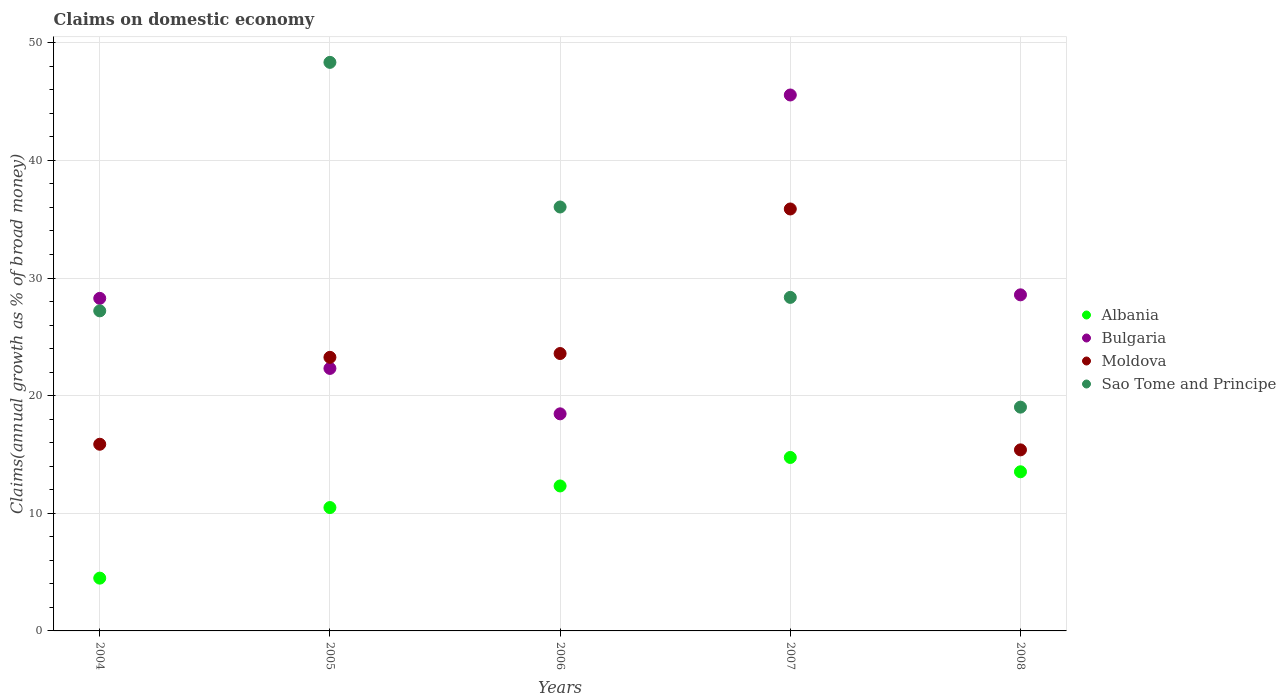How many different coloured dotlines are there?
Your answer should be compact. 4. Is the number of dotlines equal to the number of legend labels?
Your response must be concise. Yes. What is the percentage of broad money claimed on domestic economy in Moldova in 2005?
Your answer should be very brief. 23.26. Across all years, what is the maximum percentage of broad money claimed on domestic economy in Sao Tome and Principe?
Ensure brevity in your answer.  48.33. Across all years, what is the minimum percentage of broad money claimed on domestic economy in Sao Tome and Principe?
Give a very brief answer. 19.02. In which year was the percentage of broad money claimed on domestic economy in Sao Tome and Principe maximum?
Provide a short and direct response. 2005. What is the total percentage of broad money claimed on domestic economy in Bulgaria in the graph?
Keep it short and to the point. 143.17. What is the difference between the percentage of broad money claimed on domestic economy in Bulgaria in 2005 and that in 2008?
Give a very brief answer. -6.26. What is the difference between the percentage of broad money claimed on domestic economy in Albania in 2008 and the percentage of broad money claimed on domestic economy in Sao Tome and Principe in 2007?
Your response must be concise. -14.83. What is the average percentage of broad money claimed on domestic economy in Moldova per year?
Offer a very short reply. 22.79. In the year 2007, what is the difference between the percentage of broad money claimed on domestic economy in Albania and percentage of broad money claimed on domestic economy in Sao Tome and Principe?
Provide a succinct answer. -13.61. In how many years, is the percentage of broad money claimed on domestic economy in Bulgaria greater than 34 %?
Offer a terse response. 1. What is the ratio of the percentage of broad money claimed on domestic economy in Moldova in 2004 to that in 2006?
Keep it short and to the point. 0.67. Is the difference between the percentage of broad money claimed on domestic economy in Albania in 2005 and 2008 greater than the difference between the percentage of broad money claimed on domestic economy in Sao Tome and Principe in 2005 and 2008?
Give a very brief answer. No. What is the difference between the highest and the second highest percentage of broad money claimed on domestic economy in Sao Tome and Principe?
Offer a very short reply. 12.29. What is the difference between the highest and the lowest percentage of broad money claimed on domestic economy in Albania?
Offer a very short reply. 10.26. In how many years, is the percentage of broad money claimed on domestic economy in Sao Tome and Principe greater than the average percentage of broad money claimed on domestic economy in Sao Tome and Principe taken over all years?
Keep it short and to the point. 2. Is it the case that in every year, the sum of the percentage of broad money claimed on domestic economy in Sao Tome and Principe and percentage of broad money claimed on domestic economy in Bulgaria  is greater than the sum of percentage of broad money claimed on domestic economy in Albania and percentage of broad money claimed on domestic economy in Moldova?
Offer a very short reply. No. Is it the case that in every year, the sum of the percentage of broad money claimed on domestic economy in Sao Tome and Principe and percentage of broad money claimed on domestic economy in Albania  is greater than the percentage of broad money claimed on domestic economy in Moldova?
Keep it short and to the point. Yes. How many dotlines are there?
Give a very brief answer. 4. How many years are there in the graph?
Ensure brevity in your answer.  5. Are the values on the major ticks of Y-axis written in scientific E-notation?
Give a very brief answer. No. Does the graph contain any zero values?
Your response must be concise. No. How are the legend labels stacked?
Keep it short and to the point. Vertical. What is the title of the graph?
Your answer should be very brief. Claims on domestic economy. Does "Germany" appear as one of the legend labels in the graph?
Keep it short and to the point. No. What is the label or title of the Y-axis?
Give a very brief answer. Claims(annual growth as % of broad money). What is the Claims(annual growth as % of broad money) in Albania in 2004?
Give a very brief answer. 4.49. What is the Claims(annual growth as % of broad money) of Bulgaria in 2004?
Your answer should be compact. 28.27. What is the Claims(annual growth as % of broad money) in Moldova in 2004?
Ensure brevity in your answer.  15.87. What is the Claims(annual growth as % of broad money) in Sao Tome and Principe in 2004?
Provide a succinct answer. 27.21. What is the Claims(annual growth as % of broad money) of Albania in 2005?
Provide a short and direct response. 10.49. What is the Claims(annual growth as % of broad money) in Bulgaria in 2005?
Offer a very short reply. 22.32. What is the Claims(annual growth as % of broad money) of Moldova in 2005?
Ensure brevity in your answer.  23.26. What is the Claims(annual growth as % of broad money) in Sao Tome and Principe in 2005?
Provide a succinct answer. 48.33. What is the Claims(annual growth as % of broad money) of Albania in 2006?
Your answer should be compact. 12.32. What is the Claims(annual growth as % of broad money) of Bulgaria in 2006?
Offer a terse response. 18.45. What is the Claims(annual growth as % of broad money) in Moldova in 2006?
Your answer should be very brief. 23.58. What is the Claims(annual growth as % of broad money) of Sao Tome and Principe in 2006?
Your answer should be compact. 36.04. What is the Claims(annual growth as % of broad money) of Albania in 2007?
Make the answer very short. 14.75. What is the Claims(annual growth as % of broad money) in Bulgaria in 2007?
Give a very brief answer. 45.56. What is the Claims(annual growth as % of broad money) of Moldova in 2007?
Keep it short and to the point. 35.87. What is the Claims(annual growth as % of broad money) in Sao Tome and Principe in 2007?
Make the answer very short. 28.35. What is the Claims(annual growth as % of broad money) in Albania in 2008?
Your answer should be very brief. 13.53. What is the Claims(annual growth as % of broad money) of Bulgaria in 2008?
Your response must be concise. 28.57. What is the Claims(annual growth as % of broad money) of Moldova in 2008?
Ensure brevity in your answer.  15.39. What is the Claims(annual growth as % of broad money) in Sao Tome and Principe in 2008?
Keep it short and to the point. 19.02. Across all years, what is the maximum Claims(annual growth as % of broad money) in Albania?
Provide a short and direct response. 14.75. Across all years, what is the maximum Claims(annual growth as % of broad money) of Bulgaria?
Your answer should be compact. 45.56. Across all years, what is the maximum Claims(annual growth as % of broad money) of Moldova?
Give a very brief answer. 35.87. Across all years, what is the maximum Claims(annual growth as % of broad money) of Sao Tome and Principe?
Make the answer very short. 48.33. Across all years, what is the minimum Claims(annual growth as % of broad money) of Albania?
Offer a very short reply. 4.49. Across all years, what is the minimum Claims(annual growth as % of broad money) in Bulgaria?
Your answer should be compact. 18.45. Across all years, what is the minimum Claims(annual growth as % of broad money) in Moldova?
Provide a short and direct response. 15.39. Across all years, what is the minimum Claims(annual growth as % of broad money) in Sao Tome and Principe?
Offer a very short reply. 19.02. What is the total Claims(annual growth as % of broad money) in Albania in the graph?
Give a very brief answer. 55.57. What is the total Claims(annual growth as % of broad money) of Bulgaria in the graph?
Provide a succinct answer. 143.17. What is the total Claims(annual growth as % of broad money) in Moldova in the graph?
Your answer should be compact. 113.97. What is the total Claims(annual growth as % of broad money) in Sao Tome and Principe in the graph?
Offer a very short reply. 158.96. What is the difference between the Claims(annual growth as % of broad money) of Bulgaria in 2004 and that in 2005?
Your response must be concise. 5.96. What is the difference between the Claims(annual growth as % of broad money) of Moldova in 2004 and that in 2005?
Your answer should be very brief. -7.39. What is the difference between the Claims(annual growth as % of broad money) of Sao Tome and Principe in 2004 and that in 2005?
Provide a succinct answer. -21.12. What is the difference between the Claims(annual growth as % of broad money) in Albania in 2004 and that in 2006?
Offer a very short reply. -7.84. What is the difference between the Claims(annual growth as % of broad money) in Bulgaria in 2004 and that in 2006?
Ensure brevity in your answer.  9.82. What is the difference between the Claims(annual growth as % of broad money) of Moldova in 2004 and that in 2006?
Give a very brief answer. -7.71. What is the difference between the Claims(annual growth as % of broad money) in Sao Tome and Principe in 2004 and that in 2006?
Your answer should be compact. -8.83. What is the difference between the Claims(annual growth as % of broad money) in Albania in 2004 and that in 2007?
Give a very brief answer. -10.26. What is the difference between the Claims(annual growth as % of broad money) in Bulgaria in 2004 and that in 2007?
Provide a short and direct response. -17.29. What is the difference between the Claims(annual growth as % of broad money) in Moldova in 2004 and that in 2007?
Provide a succinct answer. -20. What is the difference between the Claims(annual growth as % of broad money) of Sao Tome and Principe in 2004 and that in 2007?
Give a very brief answer. -1.15. What is the difference between the Claims(annual growth as % of broad money) in Albania in 2004 and that in 2008?
Your response must be concise. -9.04. What is the difference between the Claims(annual growth as % of broad money) in Bulgaria in 2004 and that in 2008?
Offer a terse response. -0.3. What is the difference between the Claims(annual growth as % of broad money) of Moldova in 2004 and that in 2008?
Your answer should be compact. 0.48. What is the difference between the Claims(annual growth as % of broad money) of Sao Tome and Principe in 2004 and that in 2008?
Offer a very short reply. 8.18. What is the difference between the Claims(annual growth as % of broad money) of Albania in 2005 and that in 2006?
Your response must be concise. -1.84. What is the difference between the Claims(annual growth as % of broad money) of Bulgaria in 2005 and that in 2006?
Offer a terse response. 3.86. What is the difference between the Claims(annual growth as % of broad money) in Moldova in 2005 and that in 2006?
Provide a succinct answer. -0.32. What is the difference between the Claims(annual growth as % of broad money) of Sao Tome and Principe in 2005 and that in 2006?
Your answer should be compact. 12.29. What is the difference between the Claims(annual growth as % of broad money) in Albania in 2005 and that in 2007?
Provide a short and direct response. -4.26. What is the difference between the Claims(annual growth as % of broad money) of Bulgaria in 2005 and that in 2007?
Your answer should be very brief. -23.24. What is the difference between the Claims(annual growth as % of broad money) of Moldova in 2005 and that in 2007?
Provide a succinct answer. -12.61. What is the difference between the Claims(annual growth as % of broad money) of Sao Tome and Principe in 2005 and that in 2007?
Your answer should be very brief. 19.98. What is the difference between the Claims(annual growth as % of broad money) of Albania in 2005 and that in 2008?
Ensure brevity in your answer.  -3.04. What is the difference between the Claims(annual growth as % of broad money) of Bulgaria in 2005 and that in 2008?
Provide a succinct answer. -6.26. What is the difference between the Claims(annual growth as % of broad money) of Moldova in 2005 and that in 2008?
Make the answer very short. 7.87. What is the difference between the Claims(annual growth as % of broad money) of Sao Tome and Principe in 2005 and that in 2008?
Offer a terse response. 29.31. What is the difference between the Claims(annual growth as % of broad money) in Albania in 2006 and that in 2007?
Ensure brevity in your answer.  -2.42. What is the difference between the Claims(annual growth as % of broad money) in Bulgaria in 2006 and that in 2007?
Provide a short and direct response. -27.11. What is the difference between the Claims(annual growth as % of broad money) of Moldova in 2006 and that in 2007?
Provide a short and direct response. -12.29. What is the difference between the Claims(annual growth as % of broad money) in Sao Tome and Principe in 2006 and that in 2007?
Make the answer very short. 7.68. What is the difference between the Claims(annual growth as % of broad money) in Albania in 2006 and that in 2008?
Keep it short and to the point. -1.2. What is the difference between the Claims(annual growth as % of broad money) of Bulgaria in 2006 and that in 2008?
Keep it short and to the point. -10.12. What is the difference between the Claims(annual growth as % of broad money) of Moldova in 2006 and that in 2008?
Provide a short and direct response. 8.19. What is the difference between the Claims(annual growth as % of broad money) in Sao Tome and Principe in 2006 and that in 2008?
Offer a very short reply. 17.01. What is the difference between the Claims(annual growth as % of broad money) of Albania in 2007 and that in 2008?
Your answer should be compact. 1.22. What is the difference between the Claims(annual growth as % of broad money) of Bulgaria in 2007 and that in 2008?
Your response must be concise. 16.99. What is the difference between the Claims(annual growth as % of broad money) of Moldova in 2007 and that in 2008?
Provide a short and direct response. 20.48. What is the difference between the Claims(annual growth as % of broad money) of Sao Tome and Principe in 2007 and that in 2008?
Provide a short and direct response. 9.33. What is the difference between the Claims(annual growth as % of broad money) of Albania in 2004 and the Claims(annual growth as % of broad money) of Bulgaria in 2005?
Your answer should be compact. -17.83. What is the difference between the Claims(annual growth as % of broad money) of Albania in 2004 and the Claims(annual growth as % of broad money) of Moldova in 2005?
Ensure brevity in your answer.  -18.77. What is the difference between the Claims(annual growth as % of broad money) of Albania in 2004 and the Claims(annual growth as % of broad money) of Sao Tome and Principe in 2005?
Provide a short and direct response. -43.85. What is the difference between the Claims(annual growth as % of broad money) in Bulgaria in 2004 and the Claims(annual growth as % of broad money) in Moldova in 2005?
Provide a short and direct response. 5.01. What is the difference between the Claims(annual growth as % of broad money) in Bulgaria in 2004 and the Claims(annual growth as % of broad money) in Sao Tome and Principe in 2005?
Your answer should be compact. -20.06. What is the difference between the Claims(annual growth as % of broad money) of Moldova in 2004 and the Claims(annual growth as % of broad money) of Sao Tome and Principe in 2005?
Make the answer very short. -32.46. What is the difference between the Claims(annual growth as % of broad money) in Albania in 2004 and the Claims(annual growth as % of broad money) in Bulgaria in 2006?
Give a very brief answer. -13.97. What is the difference between the Claims(annual growth as % of broad money) in Albania in 2004 and the Claims(annual growth as % of broad money) in Moldova in 2006?
Provide a succinct answer. -19.09. What is the difference between the Claims(annual growth as % of broad money) of Albania in 2004 and the Claims(annual growth as % of broad money) of Sao Tome and Principe in 2006?
Provide a short and direct response. -31.55. What is the difference between the Claims(annual growth as % of broad money) in Bulgaria in 2004 and the Claims(annual growth as % of broad money) in Moldova in 2006?
Offer a terse response. 4.69. What is the difference between the Claims(annual growth as % of broad money) in Bulgaria in 2004 and the Claims(annual growth as % of broad money) in Sao Tome and Principe in 2006?
Your answer should be compact. -7.77. What is the difference between the Claims(annual growth as % of broad money) in Moldova in 2004 and the Claims(annual growth as % of broad money) in Sao Tome and Principe in 2006?
Offer a very short reply. -20.17. What is the difference between the Claims(annual growth as % of broad money) in Albania in 2004 and the Claims(annual growth as % of broad money) in Bulgaria in 2007?
Ensure brevity in your answer.  -41.07. What is the difference between the Claims(annual growth as % of broad money) in Albania in 2004 and the Claims(annual growth as % of broad money) in Moldova in 2007?
Give a very brief answer. -31.38. What is the difference between the Claims(annual growth as % of broad money) in Albania in 2004 and the Claims(annual growth as % of broad money) in Sao Tome and Principe in 2007?
Give a very brief answer. -23.87. What is the difference between the Claims(annual growth as % of broad money) in Bulgaria in 2004 and the Claims(annual growth as % of broad money) in Moldova in 2007?
Your answer should be compact. -7.6. What is the difference between the Claims(annual growth as % of broad money) of Bulgaria in 2004 and the Claims(annual growth as % of broad money) of Sao Tome and Principe in 2007?
Ensure brevity in your answer.  -0.08. What is the difference between the Claims(annual growth as % of broad money) of Moldova in 2004 and the Claims(annual growth as % of broad money) of Sao Tome and Principe in 2007?
Offer a very short reply. -12.48. What is the difference between the Claims(annual growth as % of broad money) in Albania in 2004 and the Claims(annual growth as % of broad money) in Bulgaria in 2008?
Offer a very short reply. -24.08. What is the difference between the Claims(annual growth as % of broad money) of Albania in 2004 and the Claims(annual growth as % of broad money) of Moldova in 2008?
Your answer should be compact. -10.9. What is the difference between the Claims(annual growth as % of broad money) in Albania in 2004 and the Claims(annual growth as % of broad money) in Sao Tome and Principe in 2008?
Offer a terse response. -14.54. What is the difference between the Claims(annual growth as % of broad money) of Bulgaria in 2004 and the Claims(annual growth as % of broad money) of Moldova in 2008?
Provide a succinct answer. 12.88. What is the difference between the Claims(annual growth as % of broad money) of Bulgaria in 2004 and the Claims(annual growth as % of broad money) of Sao Tome and Principe in 2008?
Ensure brevity in your answer.  9.25. What is the difference between the Claims(annual growth as % of broad money) of Moldova in 2004 and the Claims(annual growth as % of broad money) of Sao Tome and Principe in 2008?
Provide a succinct answer. -3.15. What is the difference between the Claims(annual growth as % of broad money) in Albania in 2005 and the Claims(annual growth as % of broad money) in Bulgaria in 2006?
Give a very brief answer. -7.97. What is the difference between the Claims(annual growth as % of broad money) of Albania in 2005 and the Claims(annual growth as % of broad money) of Moldova in 2006?
Provide a short and direct response. -13.09. What is the difference between the Claims(annual growth as % of broad money) in Albania in 2005 and the Claims(annual growth as % of broad money) in Sao Tome and Principe in 2006?
Ensure brevity in your answer.  -25.55. What is the difference between the Claims(annual growth as % of broad money) in Bulgaria in 2005 and the Claims(annual growth as % of broad money) in Moldova in 2006?
Offer a very short reply. -1.27. What is the difference between the Claims(annual growth as % of broad money) in Bulgaria in 2005 and the Claims(annual growth as % of broad money) in Sao Tome and Principe in 2006?
Your answer should be very brief. -13.72. What is the difference between the Claims(annual growth as % of broad money) of Moldova in 2005 and the Claims(annual growth as % of broad money) of Sao Tome and Principe in 2006?
Ensure brevity in your answer.  -12.78. What is the difference between the Claims(annual growth as % of broad money) of Albania in 2005 and the Claims(annual growth as % of broad money) of Bulgaria in 2007?
Give a very brief answer. -35.07. What is the difference between the Claims(annual growth as % of broad money) in Albania in 2005 and the Claims(annual growth as % of broad money) in Moldova in 2007?
Keep it short and to the point. -25.38. What is the difference between the Claims(annual growth as % of broad money) of Albania in 2005 and the Claims(annual growth as % of broad money) of Sao Tome and Principe in 2007?
Your answer should be very brief. -17.87. What is the difference between the Claims(annual growth as % of broad money) in Bulgaria in 2005 and the Claims(annual growth as % of broad money) in Moldova in 2007?
Offer a terse response. -13.55. What is the difference between the Claims(annual growth as % of broad money) of Bulgaria in 2005 and the Claims(annual growth as % of broad money) of Sao Tome and Principe in 2007?
Your answer should be very brief. -6.04. What is the difference between the Claims(annual growth as % of broad money) in Moldova in 2005 and the Claims(annual growth as % of broad money) in Sao Tome and Principe in 2007?
Give a very brief answer. -5.1. What is the difference between the Claims(annual growth as % of broad money) of Albania in 2005 and the Claims(annual growth as % of broad money) of Bulgaria in 2008?
Your answer should be very brief. -18.08. What is the difference between the Claims(annual growth as % of broad money) in Albania in 2005 and the Claims(annual growth as % of broad money) in Moldova in 2008?
Your answer should be very brief. -4.9. What is the difference between the Claims(annual growth as % of broad money) in Albania in 2005 and the Claims(annual growth as % of broad money) in Sao Tome and Principe in 2008?
Ensure brevity in your answer.  -8.54. What is the difference between the Claims(annual growth as % of broad money) of Bulgaria in 2005 and the Claims(annual growth as % of broad money) of Moldova in 2008?
Your response must be concise. 6.92. What is the difference between the Claims(annual growth as % of broad money) in Bulgaria in 2005 and the Claims(annual growth as % of broad money) in Sao Tome and Principe in 2008?
Give a very brief answer. 3.29. What is the difference between the Claims(annual growth as % of broad money) in Moldova in 2005 and the Claims(annual growth as % of broad money) in Sao Tome and Principe in 2008?
Offer a very short reply. 4.23. What is the difference between the Claims(annual growth as % of broad money) of Albania in 2006 and the Claims(annual growth as % of broad money) of Bulgaria in 2007?
Provide a short and direct response. -33.24. What is the difference between the Claims(annual growth as % of broad money) in Albania in 2006 and the Claims(annual growth as % of broad money) in Moldova in 2007?
Your response must be concise. -23.55. What is the difference between the Claims(annual growth as % of broad money) of Albania in 2006 and the Claims(annual growth as % of broad money) of Sao Tome and Principe in 2007?
Your answer should be very brief. -16.03. What is the difference between the Claims(annual growth as % of broad money) of Bulgaria in 2006 and the Claims(annual growth as % of broad money) of Moldova in 2007?
Your answer should be compact. -17.41. What is the difference between the Claims(annual growth as % of broad money) of Bulgaria in 2006 and the Claims(annual growth as % of broad money) of Sao Tome and Principe in 2007?
Offer a very short reply. -9.9. What is the difference between the Claims(annual growth as % of broad money) of Moldova in 2006 and the Claims(annual growth as % of broad money) of Sao Tome and Principe in 2007?
Make the answer very short. -4.77. What is the difference between the Claims(annual growth as % of broad money) of Albania in 2006 and the Claims(annual growth as % of broad money) of Bulgaria in 2008?
Keep it short and to the point. -16.25. What is the difference between the Claims(annual growth as % of broad money) in Albania in 2006 and the Claims(annual growth as % of broad money) in Moldova in 2008?
Your response must be concise. -3.07. What is the difference between the Claims(annual growth as % of broad money) of Albania in 2006 and the Claims(annual growth as % of broad money) of Sao Tome and Principe in 2008?
Keep it short and to the point. -6.7. What is the difference between the Claims(annual growth as % of broad money) of Bulgaria in 2006 and the Claims(annual growth as % of broad money) of Moldova in 2008?
Provide a short and direct response. 3.06. What is the difference between the Claims(annual growth as % of broad money) in Bulgaria in 2006 and the Claims(annual growth as % of broad money) in Sao Tome and Principe in 2008?
Provide a short and direct response. -0.57. What is the difference between the Claims(annual growth as % of broad money) of Moldova in 2006 and the Claims(annual growth as % of broad money) of Sao Tome and Principe in 2008?
Provide a short and direct response. 4.56. What is the difference between the Claims(annual growth as % of broad money) in Albania in 2007 and the Claims(annual growth as % of broad money) in Bulgaria in 2008?
Your answer should be very brief. -13.82. What is the difference between the Claims(annual growth as % of broad money) of Albania in 2007 and the Claims(annual growth as % of broad money) of Moldova in 2008?
Offer a terse response. -0.65. What is the difference between the Claims(annual growth as % of broad money) in Albania in 2007 and the Claims(annual growth as % of broad money) in Sao Tome and Principe in 2008?
Your answer should be compact. -4.28. What is the difference between the Claims(annual growth as % of broad money) of Bulgaria in 2007 and the Claims(annual growth as % of broad money) of Moldova in 2008?
Your response must be concise. 30.17. What is the difference between the Claims(annual growth as % of broad money) in Bulgaria in 2007 and the Claims(annual growth as % of broad money) in Sao Tome and Principe in 2008?
Offer a terse response. 26.54. What is the difference between the Claims(annual growth as % of broad money) in Moldova in 2007 and the Claims(annual growth as % of broad money) in Sao Tome and Principe in 2008?
Keep it short and to the point. 16.85. What is the average Claims(annual growth as % of broad money) in Albania per year?
Provide a short and direct response. 11.11. What is the average Claims(annual growth as % of broad money) of Bulgaria per year?
Your answer should be very brief. 28.63. What is the average Claims(annual growth as % of broad money) in Moldova per year?
Ensure brevity in your answer.  22.79. What is the average Claims(annual growth as % of broad money) of Sao Tome and Principe per year?
Offer a terse response. 31.79. In the year 2004, what is the difference between the Claims(annual growth as % of broad money) in Albania and Claims(annual growth as % of broad money) in Bulgaria?
Make the answer very short. -23.78. In the year 2004, what is the difference between the Claims(annual growth as % of broad money) in Albania and Claims(annual growth as % of broad money) in Moldova?
Give a very brief answer. -11.38. In the year 2004, what is the difference between the Claims(annual growth as % of broad money) of Albania and Claims(annual growth as % of broad money) of Sao Tome and Principe?
Keep it short and to the point. -22.72. In the year 2004, what is the difference between the Claims(annual growth as % of broad money) of Bulgaria and Claims(annual growth as % of broad money) of Moldova?
Keep it short and to the point. 12.4. In the year 2004, what is the difference between the Claims(annual growth as % of broad money) in Bulgaria and Claims(annual growth as % of broad money) in Sao Tome and Principe?
Provide a succinct answer. 1.06. In the year 2004, what is the difference between the Claims(annual growth as % of broad money) in Moldova and Claims(annual growth as % of broad money) in Sao Tome and Principe?
Your answer should be very brief. -11.34. In the year 2005, what is the difference between the Claims(annual growth as % of broad money) of Albania and Claims(annual growth as % of broad money) of Bulgaria?
Provide a short and direct response. -11.83. In the year 2005, what is the difference between the Claims(annual growth as % of broad money) in Albania and Claims(annual growth as % of broad money) in Moldova?
Your answer should be compact. -12.77. In the year 2005, what is the difference between the Claims(annual growth as % of broad money) of Albania and Claims(annual growth as % of broad money) of Sao Tome and Principe?
Give a very brief answer. -37.85. In the year 2005, what is the difference between the Claims(annual growth as % of broad money) of Bulgaria and Claims(annual growth as % of broad money) of Moldova?
Your response must be concise. -0.94. In the year 2005, what is the difference between the Claims(annual growth as % of broad money) of Bulgaria and Claims(annual growth as % of broad money) of Sao Tome and Principe?
Your answer should be very brief. -26.02. In the year 2005, what is the difference between the Claims(annual growth as % of broad money) of Moldova and Claims(annual growth as % of broad money) of Sao Tome and Principe?
Offer a terse response. -25.08. In the year 2006, what is the difference between the Claims(annual growth as % of broad money) of Albania and Claims(annual growth as % of broad money) of Bulgaria?
Offer a terse response. -6.13. In the year 2006, what is the difference between the Claims(annual growth as % of broad money) of Albania and Claims(annual growth as % of broad money) of Moldova?
Keep it short and to the point. -11.26. In the year 2006, what is the difference between the Claims(annual growth as % of broad money) of Albania and Claims(annual growth as % of broad money) of Sao Tome and Principe?
Provide a short and direct response. -23.71. In the year 2006, what is the difference between the Claims(annual growth as % of broad money) in Bulgaria and Claims(annual growth as % of broad money) in Moldova?
Your answer should be compact. -5.13. In the year 2006, what is the difference between the Claims(annual growth as % of broad money) of Bulgaria and Claims(annual growth as % of broad money) of Sao Tome and Principe?
Ensure brevity in your answer.  -17.58. In the year 2006, what is the difference between the Claims(annual growth as % of broad money) in Moldova and Claims(annual growth as % of broad money) in Sao Tome and Principe?
Make the answer very short. -12.46. In the year 2007, what is the difference between the Claims(annual growth as % of broad money) in Albania and Claims(annual growth as % of broad money) in Bulgaria?
Give a very brief answer. -30.81. In the year 2007, what is the difference between the Claims(annual growth as % of broad money) of Albania and Claims(annual growth as % of broad money) of Moldova?
Provide a succinct answer. -21.12. In the year 2007, what is the difference between the Claims(annual growth as % of broad money) of Albania and Claims(annual growth as % of broad money) of Sao Tome and Principe?
Keep it short and to the point. -13.61. In the year 2007, what is the difference between the Claims(annual growth as % of broad money) of Bulgaria and Claims(annual growth as % of broad money) of Moldova?
Provide a short and direct response. 9.69. In the year 2007, what is the difference between the Claims(annual growth as % of broad money) of Bulgaria and Claims(annual growth as % of broad money) of Sao Tome and Principe?
Keep it short and to the point. 17.21. In the year 2007, what is the difference between the Claims(annual growth as % of broad money) of Moldova and Claims(annual growth as % of broad money) of Sao Tome and Principe?
Offer a terse response. 7.52. In the year 2008, what is the difference between the Claims(annual growth as % of broad money) in Albania and Claims(annual growth as % of broad money) in Bulgaria?
Keep it short and to the point. -15.04. In the year 2008, what is the difference between the Claims(annual growth as % of broad money) in Albania and Claims(annual growth as % of broad money) in Moldova?
Make the answer very short. -1.86. In the year 2008, what is the difference between the Claims(annual growth as % of broad money) in Albania and Claims(annual growth as % of broad money) in Sao Tome and Principe?
Your response must be concise. -5.5. In the year 2008, what is the difference between the Claims(annual growth as % of broad money) of Bulgaria and Claims(annual growth as % of broad money) of Moldova?
Provide a short and direct response. 13.18. In the year 2008, what is the difference between the Claims(annual growth as % of broad money) of Bulgaria and Claims(annual growth as % of broad money) of Sao Tome and Principe?
Provide a short and direct response. 9.55. In the year 2008, what is the difference between the Claims(annual growth as % of broad money) of Moldova and Claims(annual growth as % of broad money) of Sao Tome and Principe?
Your response must be concise. -3.63. What is the ratio of the Claims(annual growth as % of broad money) in Albania in 2004 to that in 2005?
Ensure brevity in your answer.  0.43. What is the ratio of the Claims(annual growth as % of broad money) in Bulgaria in 2004 to that in 2005?
Provide a succinct answer. 1.27. What is the ratio of the Claims(annual growth as % of broad money) in Moldova in 2004 to that in 2005?
Ensure brevity in your answer.  0.68. What is the ratio of the Claims(annual growth as % of broad money) of Sao Tome and Principe in 2004 to that in 2005?
Provide a succinct answer. 0.56. What is the ratio of the Claims(annual growth as % of broad money) in Albania in 2004 to that in 2006?
Offer a very short reply. 0.36. What is the ratio of the Claims(annual growth as % of broad money) in Bulgaria in 2004 to that in 2006?
Make the answer very short. 1.53. What is the ratio of the Claims(annual growth as % of broad money) of Moldova in 2004 to that in 2006?
Your answer should be very brief. 0.67. What is the ratio of the Claims(annual growth as % of broad money) in Sao Tome and Principe in 2004 to that in 2006?
Keep it short and to the point. 0.76. What is the ratio of the Claims(annual growth as % of broad money) in Albania in 2004 to that in 2007?
Make the answer very short. 0.3. What is the ratio of the Claims(annual growth as % of broad money) of Bulgaria in 2004 to that in 2007?
Your answer should be very brief. 0.62. What is the ratio of the Claims(annual growth as % of broad money) of Moldova in 2004 to that in 2007?
Your answer should be compact. 0.44. What is the ratio of the Claims(annual growth as % of broad money) in Sao Tome and Principe in 2004 to that in 2007?
Provide a short and direct response. 0.96. What is the ratio of the Claims(annual growth as % of broad money) in Albania in 2004 to that in 2008?
Keep it short and to the point. 0.33. What is the ratio of the Claims(annual growth as % of broad money) of Moldova in 2004 to that in 2008?
Give a very brief answer. 1.03. What is the ratio of the Claims(annual growth as % of broad money) of Sao Tome and Principe in 2004 to that in 2008?
Your answer should be compact. 1.43. What is the ratio of the Claims(annual growth as % of broad money) in Albania in 2005 to that in 2006?
Keep it short and to the point. 0.85. What is the ratio of the Claims(annual growth as % of broad money) of Bulgaria in 2005 to that in 2006?
Keep it short and to the point. 1.21. What is the ratio of the Claims(annual growth as % of broad money) of Moldova in 2005 to that in 2006?
Give a very brief answer. 0.99. What is the ratio of the Claims(annual growth as % of broad money) in Sao Tome and Principe in 2005 to that in 2006?
Give a very brief answer. 1.34. What is the ratio of the Claims(annual growth as % of broad money) of Albania in 2005 to that in 2007?
Provide a short and direct response. 0.71. What is the ratio of the Claims(annual growth as % of broad money) of Bulgaria in 2005 to that in 2007?
Ensure brevity in your answer.  0.49. What is the ratio of the Claims(annual growth as % of broad money) of Moldova in 2005 to that in 2007?
Your answer should be compact. 0.65. What is the ratio of the Claims(annual growth as % of broad money) of Sao Tome and Principe in 2005 to that in 2007?
Ensure brevity in your answer.  1.7. What is the ratio of the Claims(annual growth as % of broad money) of Albania in 2005 to that in 2008?
Ensure brevity in your answer.  0.78. What is the ratio of the Claims(annual growth as % of broad money) in Bulgaria in 2005 to that in 2008?
Offer a terse response. 0.78. What is the ratio of the Claims(annual growth as % of broad money) of Moldova in 2005 to that in 2008?
Keep it short and to the point. 1.51. What is the ratio of the Claims(annual growth as % of broad money) in Sao Tome and Principe in 2005 to that in 2008?
Ensure brevity in your answer.  2.54. What is the ratio of the Claims(annual growth as % of broad money) in Albania in 2006 to that in 2007?
Make the answer very short. 0.84. What is the ratio of the Claims(annual growth as % of broad money) of Bulgaria in 2006 to that in 2007?
Offer a terse response. 0.41. What is the ratio of the Claims(annual growth as % of broad money) in Moldova in 2006 to that in 2007?
Give a very brief answer. 0.66. What is the ratio of the Claims(annual growth as % of broad money) in Sao Tome and Principe in 2006 to that in 2007?
Provide a short and direct response. 1.27. What is the ratio of the Claims(annual growth as % of broad money) of Albania in 2006 to that in 2008?
Ensure brevity in your answer.  0.91. What is the ratio of the Claims(annual growth as % of broad money) in Bulgaria in 2006 to that in 2008?
Give a very brief answer. 0.65. What is the ratio of the Claims(annual growth as % of broad money) in Moldova in 2006 to that in 2008?
Offer a terse response. 1.53. What is the ratio of the Claims(annual growth as % of broad money) in Sao Tome and Principe in 2006 to that in 2008?
Offer a very short reply. 1.89. What is the ratio of the Claims(annual growth as % of broad money) of Albania in 2007 to that in 2008?
Your response must be concise. 1.09. What is the ratio of the Claims(annual growth as % of broad money) in Bulgaria in 2007 to that in 2008?
Provide a short and direct response. 1.59. What is the ratio of the Claims(annual growth as % of broad money) in Moldova in 2007 to that in 2008?
Provide a short and direct response. 2.33. What is the ratio of the Claims(annual growth as % of broad money) of Sao Tome and Principe in 2007 to that in 2008?
Provide a short and direct response. 1.49. What is the difference between the highest and the second highest Claims(annual growth as % of broad money) in Albania?
Offer a very short reply. 1.22. What is the difference between the highest and the second highest Claims(annual growth as % of broad money) in Bulgaria?
Your answer should be compact. 16.99. What is the difference between the highest and the second highest Claims(annual growth as % of broad money) of Moldova?
Provide a short and direct response. 12.29. What is the difference between the highest and the second highest Claims(annual growth as % of broad money) in Sao Tome and Principe?
Your answer should be very brief. 12.29. What is the difference between the highest and the lowest Claims(annual growth as % of broad money) in Albania?
Offer a terse response. 10.26. What is the difference between the highest and the lowest Claims(annual growth as % of broad money) in Bulgaria?
Provide a short and direct response. 27.11. What is the difference between the highest and the lowest Claims(annual growth as % of broad money) in Moldova?
Your answer should be compact. 20.48. What is the difference between the highest and the lowest Claims(annual growth as % of broad money) of Sao Tome and Principe?
Make the answer very short. 29.31. 